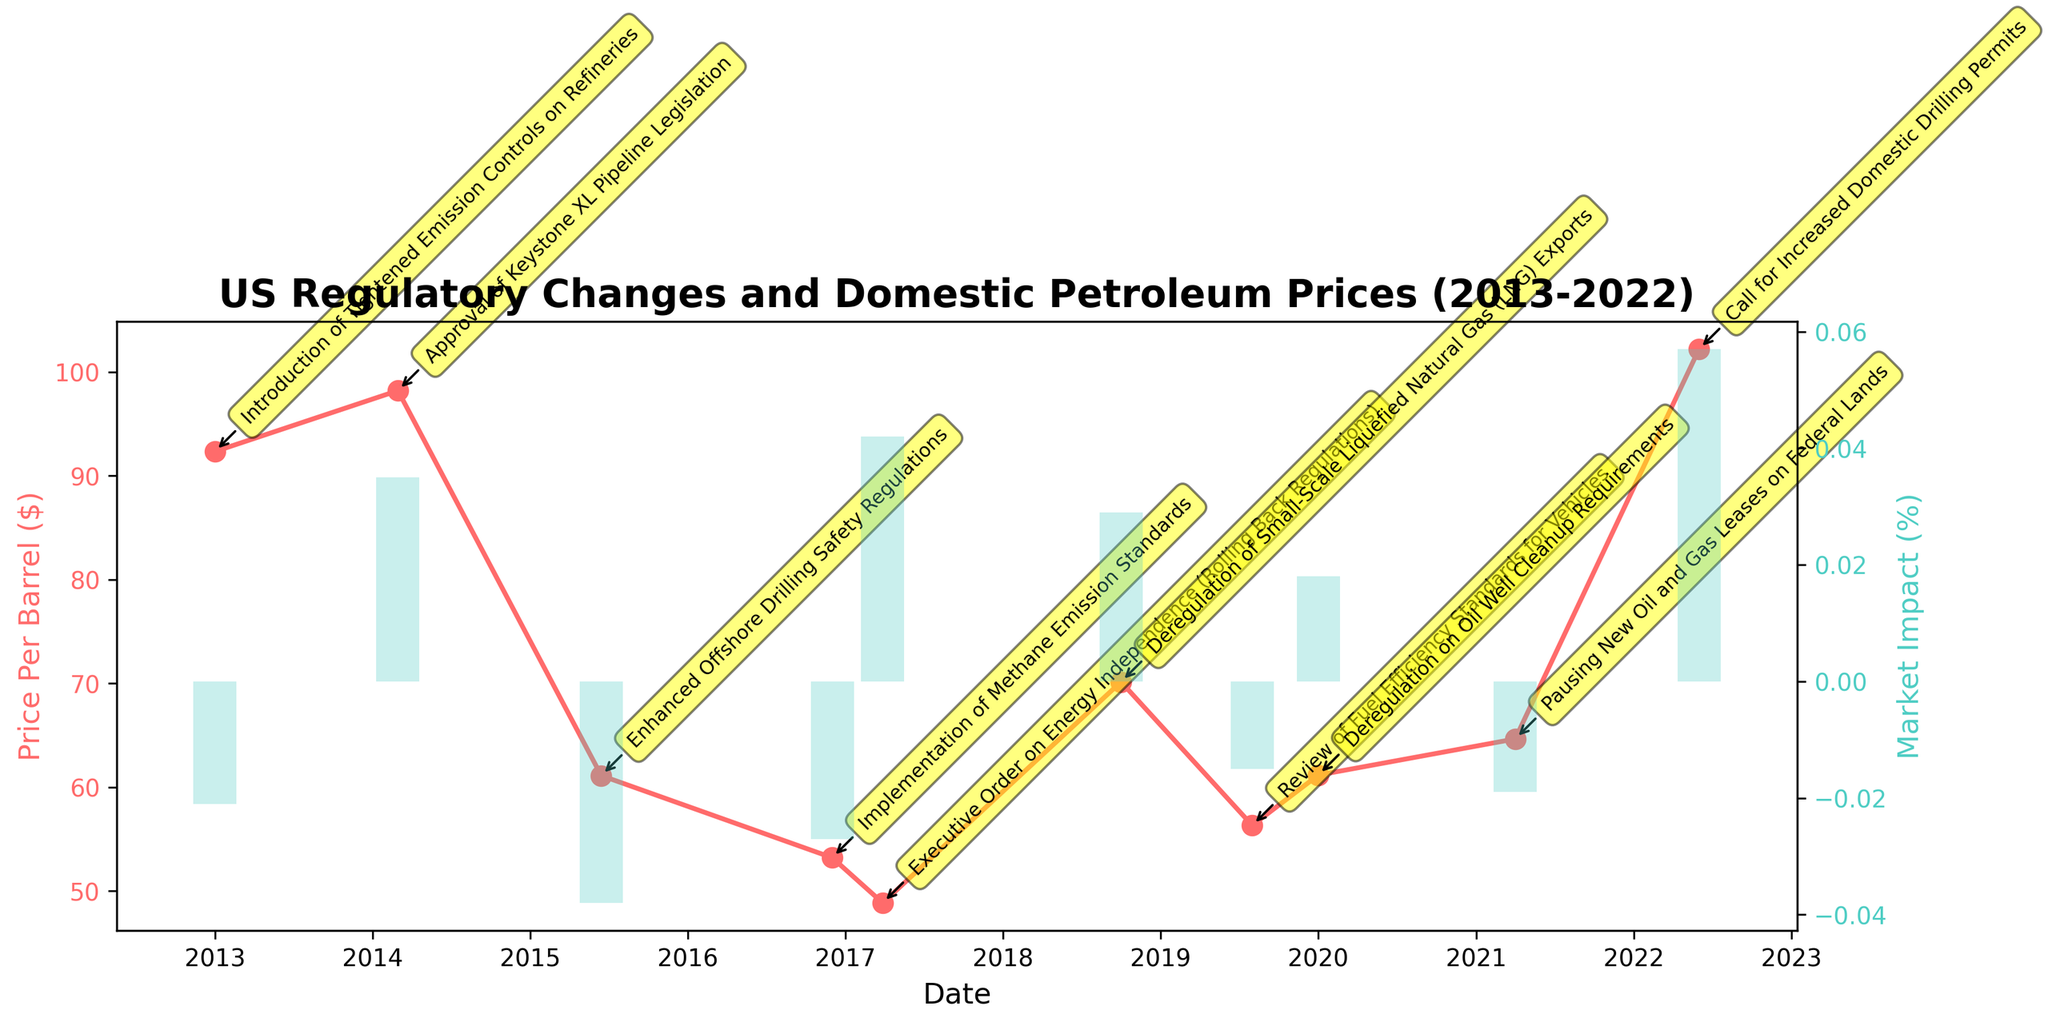What is the title of the plot? The title is displayed at the top of the figure. By looking at the top, we can read the complete title.
Answer: US Regulatory Changes and Domestic Petroleum Prices (2013-2022) What is the price per barrel of petroleum in June 2022? Locate the date June 2022 on the x-axis and align it with the y-axis showing the price per barrel.
Answer: $102.21 Which regulatory event is associated with the highest market impact percentage? Identify the tallest bar in the plot, then check the corresponding date and regulatory event for that bar.
Answer: Call for Increased Domestic Drilling Permits What was the market impact percentage after the Executive Order on Energy Independence in March 2017? Find the label for the Executive Order on Energy Independence in March 2017, then look at the height of the corresponding bar and convert it to a percentage.
Answer: +4.2% How did the price per barrel change from January 2013 to March 2014? Locate the points for January 2013 and March 2014 on the x-axis, read their price values on the y-axis, and calculate the difference.
Answer: Increased by $5.87 What is the average price per barrel from 2013 to 2022? Add up all the individual price per barrel values and divide by the total number of data points (10 years).
Answer: $70.52 Which year experienced the highest decrease in price per barrel following a regulatory event? Compare the decrease in price per barrel for each regulatory event and identify the largest drop.
Answer: 2015 (Enhanced Offshore Drilling Safety Regulations) How did the price per barrel react to the Introduction of Tightened Emission Controls on Refineries in January 2013? Locate the event on the x-axis and check whether the price per barrel moved up or down right after the event.
Answer: Decreased by 2.1% Compare the market impacts of deregulation events versus regulatory tightening events. Which had more significant positive impacts? Identify and compare the market impact bars of deregulation events and regulatory tightening events. Look for the size of positive impacts.
Answer: Deregulation events had more significant positive impacts Which regulatory event marked the beginning of a clear upward trend in petroleum prices in the last decade? Observe the timeline and price per barrel data points for a clear upward trend and identify the event coinciding with the start of this trend.
Answer: Deregulation of Small-Scale Liquefied Natural Gas (LNG) Exports in October 2018 